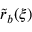Convert formula to latex. <formula><loc_0><loc_0><loc_500><loc_500>\tilde { r } _ { b } ( \xi )</formula> 